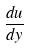Convert formula to latex. <formula><loc_0><loc_0><loc_500><loc_500>\frac { d u } { d y }</formula> 